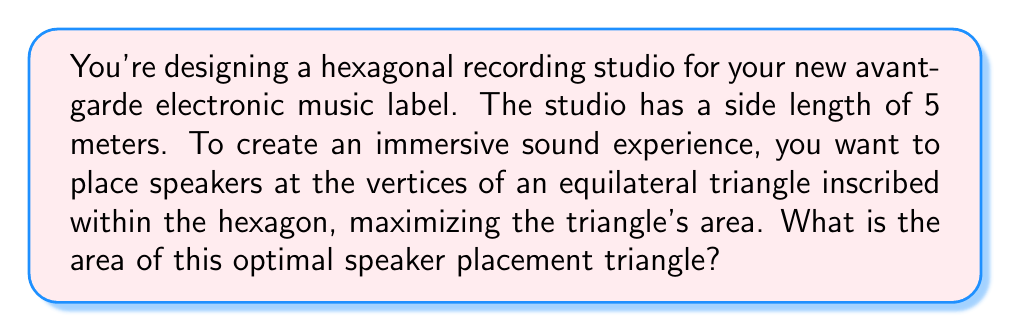Solve this math problem. Let's approach this step-by-step:

1) First, we need to find the radius of the circumscribed circle of the hexagon. In a regular hexagon, this radius is equal to the side length. So, $R = 5$ meters.

2) The center of this circle coincides with the center of the hexagon. We can inscribe the equilateral triangle such that one of its vertices touches a vertex of the hexagon, and its center coincides with the hexagon's center.

3) Let's call the side length of this inscribed equilateral triangle $a$. We can split this triangle into six congruent right triangles.

4) In one of these right triangles:
   - The hypotenuse is $R = 5$
   - One leg is $a/2$
   - The angle between them is 30°

5) Using trigonometry:

   $$\sin 30° = \frac{a/2}{5}$$

6) We know that $\sin 30° = \frac{1}{2}$, so:

   $$\frac{1}{2} = \frac{a/2}{5}$$

7) Solving for $a$:

   $$a = 5$$

8) Now that we have the side length of the equilateral triangle, we can calculate its area using the formula:

   $$A = \frac{\sqrt{3}}{4}a^2$$

9) Substituting $a = 5$:

   $$A = \frac{\sqrt{3}}{4}(5^2) = \frac{25\sqrt{3}}{4}$$

Therefore, the area of the optimal speaker placement triangle is $\frac{25\sqrt{3}}{4}$ square meters.
Answer: $\frac{25\sqrt{3}}{4}$ m² 